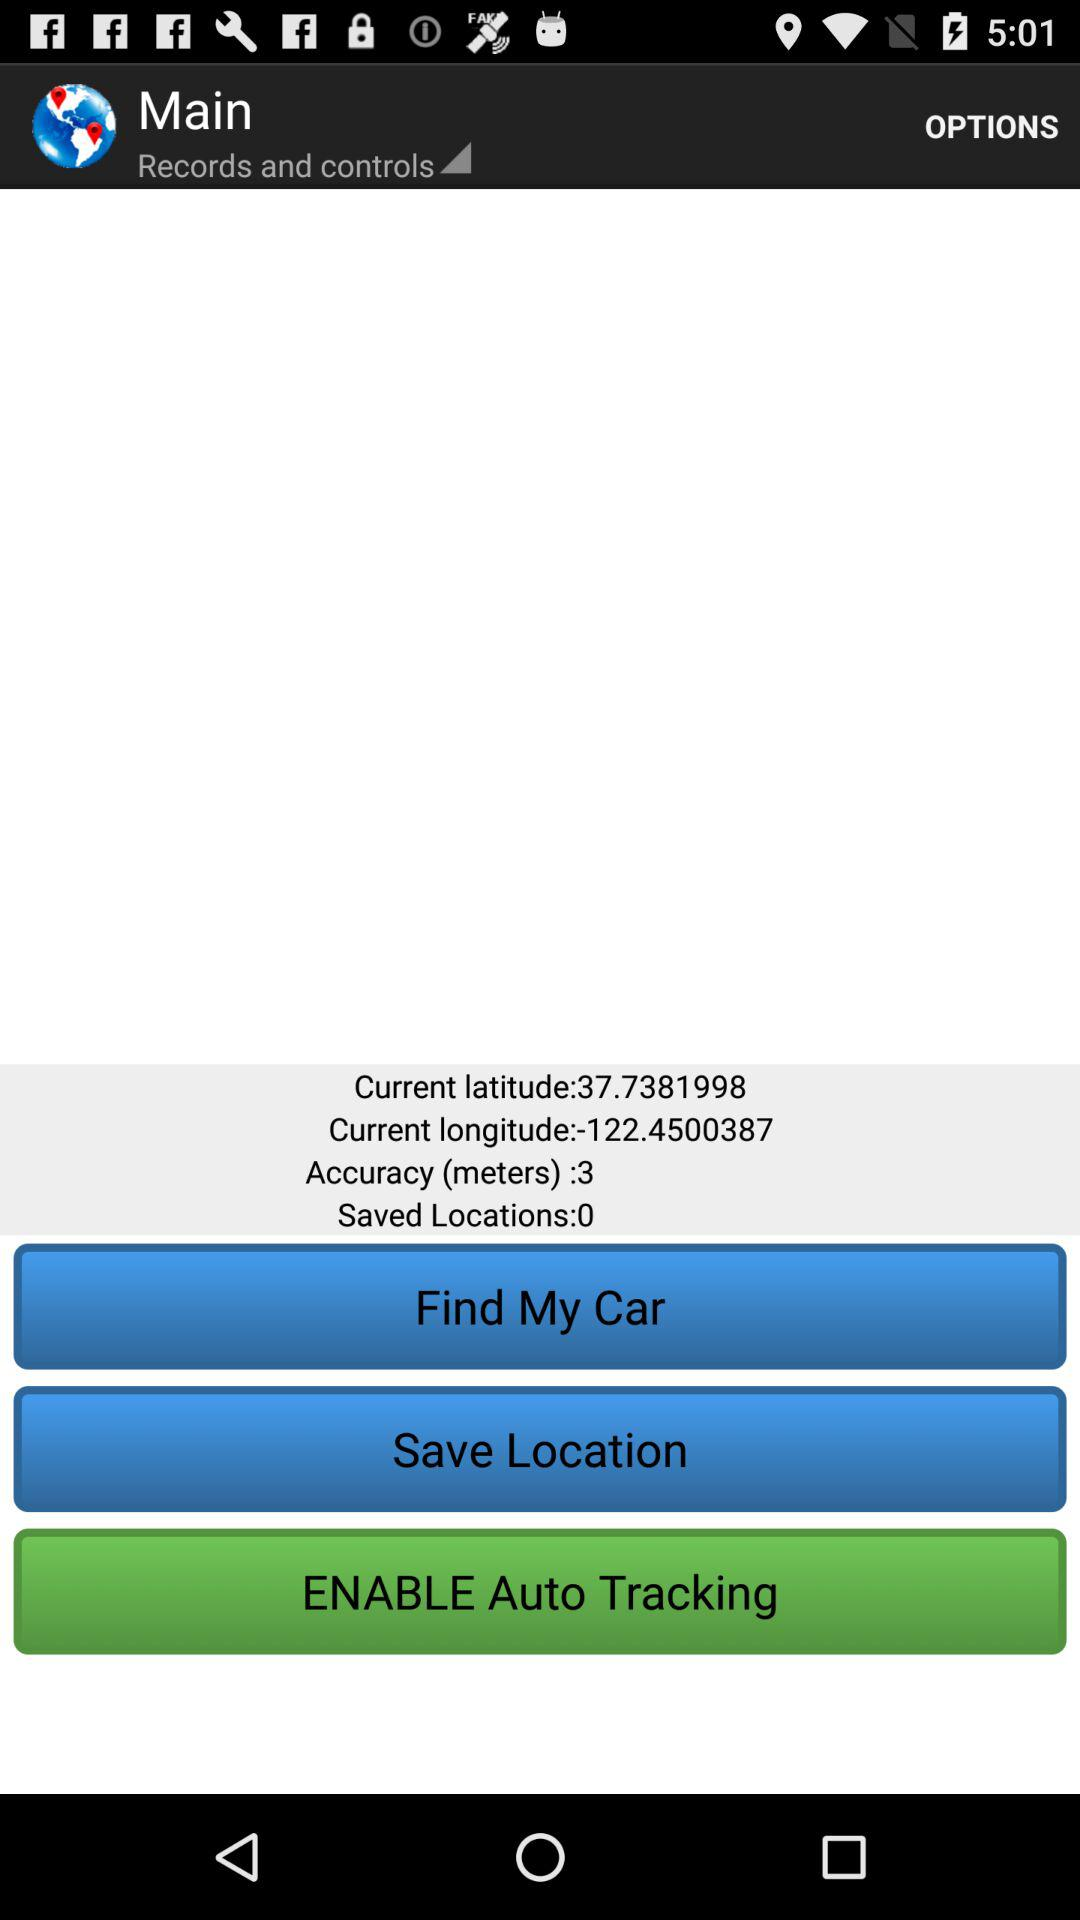What is the current measured value of longitude? The current measured value of longitude is -122.4500387. 